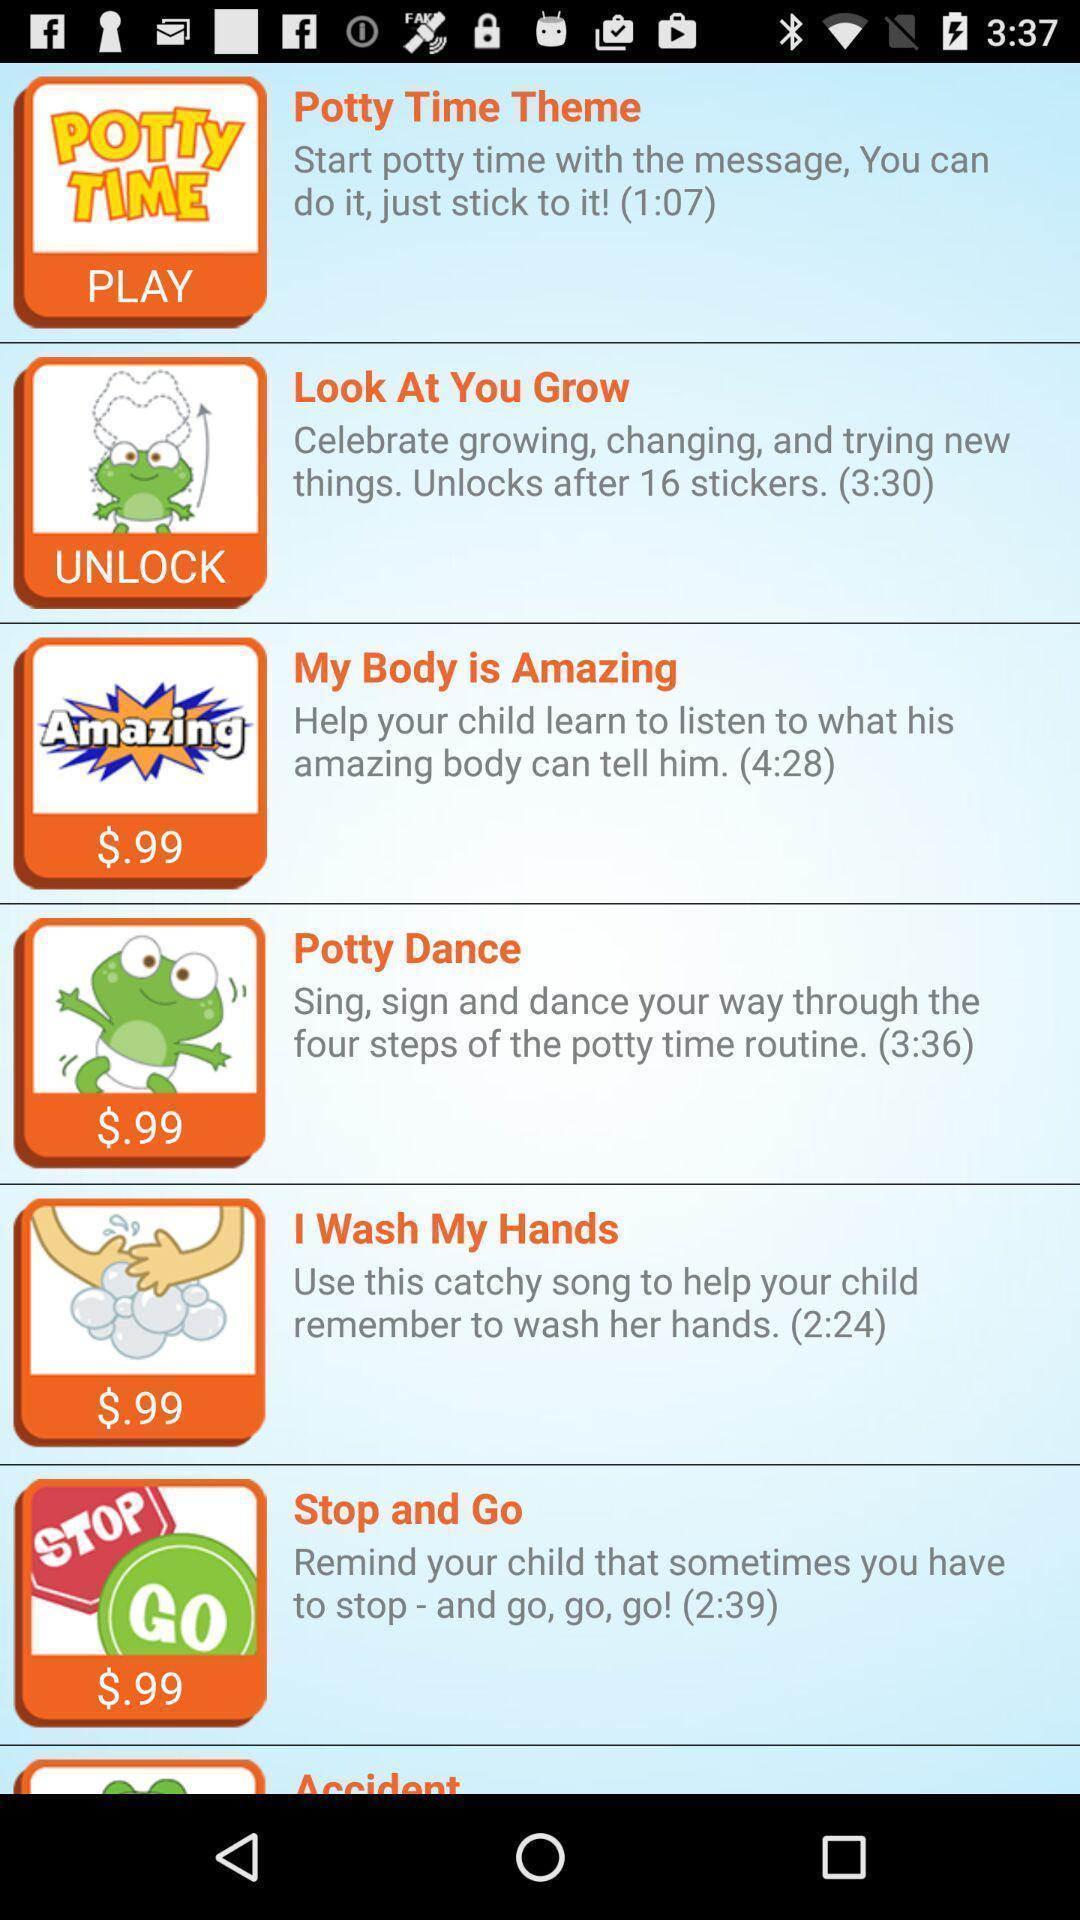Describe this image in words. Page showing different child education exercises. 